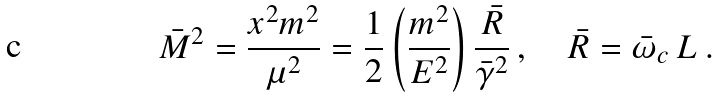<formula> <loc_0><loc_0><loc_500><loc_500>\bar { M } ^ { 2 } = \frac { x ^ { 2 } m ^ { 2 } } { \mu ^ { 2 } } = \frac { 1 } { 2 } \left ( \frac { m ^ { 2 } } { E ^ { 2 } } \right ) \frac { \bar { R } } { \bar { \gamma } ^ { 2 } } \, , \quad \bar { R } = \bar { \omega } _ { c } \, L \, .</formula> 